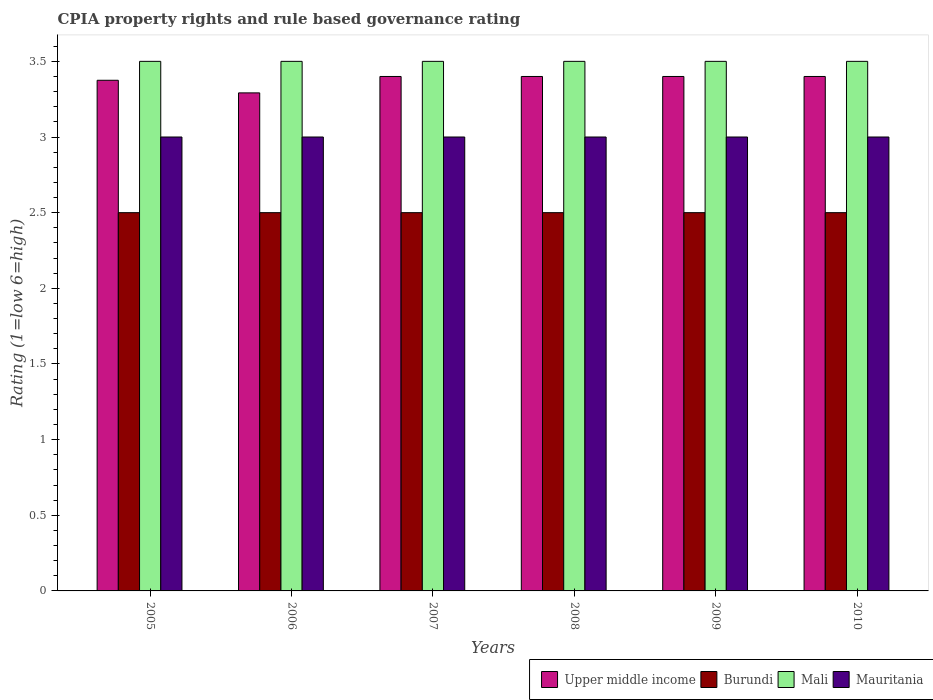How many different coloured bars are there?
Make the answer very short. 4. Are the number of bars on each tick of the X-axis equal?
Ensure brevity in your answer.  Yes. What is the label of the 2nd group of bars from the left?
Ensure brevity in your answer.  2006. What is the CPIA rating in Burundi in 2009?
Keep it short and to the point. 2.5. Across all years, what is the minimum CPIA rating in Mauritania?
Provide a succinct answer. 3. What is the total CPIA rating in Mauritania in the graph?
Provide a succinct answer. 18. What is the difference between the CPIA rating in Upper middle income in 2005 and that in 2010?
Ensure brevity in your answer.  -0.02. What is the difference between the CPIA rating in Burundi in 2008 and the CPIA rating in Upper middle income in 2007?
Your answer should be compact. -0.9. What is the average CPIA rating in Upper middle income per year?
Ensure brevity in your answer.  3.38. In how many years, is the CPIA rating in Upper middle income greater than 3.3?
Your answer should be compact. 5. Is the difference between the CPIA rating in Mauritania in 2007 and 2009 greater than the difference between the CPIA rating in Burundi in 2007 and 2009?
Offer a very short reply. No. What is the difference between the highest and the lowest CPIA rating in Mauritania?
Your answer should be compact. 0. In how many years, is the CPIA rating in Upper middle income greater than the average CPIA rating in Upper middle income taken over all years?
Your answer should be compact. 4. Is it the case that in every year, the sum of the CPIA rating in Mauritania and CPIA rating in Burundi is greater than the sum of CPIA rating in Upper middle income and CPIA rating in Mali?
Offer a terse response. Yes. What does the 4th bar from the left in 2006 represents?
Provide a short and direct response. Mauritania. What does the 1st bar from the right in 2006 represents?
Offer a terse response. Mauritania. How many bars are there?
Your answer should be very brief. 24. What is the difference between two consecutive major ticks on the Y-axis?
Ensure brevity in your answer.  0.5. Does the graph contain any zero values?
Ensure brevity in your answer.  No. Does the graph contain grids?
Ensure brevity in your answer.  No. Where does the legend appear in the graph?
Your answer should be very brief. Bottom right. How many legend labels are there?
Keep it short and to the point. 4. How are the legend labels stacked?
Provide a succinct answer. Horizontal. What is the title of the graph?
Keep it short and to the point. CPIA property rights and rule based governance rating. What is the label or title of the X-axis?
Your answer should be very brief. Years. What is the label or title of the Y-axis?
Give a very brief answer. Rating (1=low 6=high). What is the Rating (1=low 6=high) in Upper middle income in 2005?
Your answer should be compact. 3.38. What is the Rating (1=low 6=high) of Upper middle income in 2006?
Offer a very short reply. 3.29. What is the Rating (1=low 6=high) in Burundi in 2006?
Provide a succinct answer. 2.5. What is the Rating (1=low 6=high) in Upper middle income in 2007?
Offer a very short reply. 3.4. What is the Rating (1=low 6=high) of Mauritania in 2007?
Your response must be concise. 3. What is the Rating (1=low 6=high) of Burundi in 2008?
Your answer should be compact. 2.5. What is the Rating (1=low 6=high) of Mali in 2008?
Your response must be concise. 3.5. What is the Rating (1=low 6=high) of Mauritania in 2008?
Provide a short and direct response. 3. What is the Rating (1=low 6=high) of Burundi in 2009?
Ensure brevity in your answer.  2.5. What is the Rating (1=low 6=high) in Mali in 2009?
Offer a terse response. 3.5. What is the Rating (1=low 6=high) of Mauritania in 2009?
Provide a short and direct response. 3. What is the Rating (1=low 6=high) of Upper middle income in 2010?
Your response must be concise. 3.4. What is the Rating (1=low 6=high) in Mali in 2010?
Offer a terse response. 3.5. What is the Rating (1=low 6=high) of Mauritania in 2010?
Give a very brief answer. 3. Across all years, what is the maximum Rating (1=low 6=high) in Burundi?
Your response must be concise. 2.5. Across all years, what is the maximum Rating (1=low 6=high) of Mali?
Make the answer very short. 3.5. Across all years, what is the minimum Rating (1=low 6=high) in Upper middle income?
Offer a very short reply. 3.29. Across all years, what is the minimum Rating (1=low 6=high) of Burundi?
Offer a very short reply. 2.5. Across all years, what is the minimum Rating (1=low 6=high) in Mali?
Offer a very short reply. 3.5. What is the total Rating (1=low 6=high) in Upper middle income in the graph?
Provide a succinct answer. 20.27. What is the total Rating (1=low 6=high) in Mali in the graph?
Your answer should be compact. 21. What is the difference between the Rating (1=low 6=high) of Upper middle income in 2005 and that in 2006?
Provide a succinct answer. 0.08. What is the difference between the Rating (1=low 6=high) in Mauritania in 2005 and that in 2006?
Your answer should be very brief. 0. What is the difference between the Rating (1=low 6=high) of Upper middle income in 2005 and that in 2007?
Your answer should be very brief. -0.03. What is the difference between the Rating (1=low 6=high) of Upper middle income in 2005 and that in 2008?
Ensure brevity in your answer.  -0.03. What is the difference between the Rating (1=low 6=high) in Burundi in 2005 and that in 2008?
Offer a very short reply. 0. What is the difference between the Rating (1=low 6=high) of Mali in 2005 and that in 2008?
Give a very brief answer. 0. What is the difference between the Rating (1=low 6=high) in Upper middle income in 2005 and that in 2009?
Your answer should be compact. -0.03. What is the difference between the Rating (1=low 6=high) in Mali in 2005 and that in 2009?
Provide a short and direct response. 0. What is the difference between the Rating (1=low 6=high) in Mauritania in 2005 and that in 2009?
Ensure brevity in your answer.  0. What is the difference between the Rating (1=low 6=high) of Upper middle income in 2005 and that in 2010?
Ensure brevity in your answer.  -0.03. What is the difference between the Rating (1=low 6=high) of Burundi in 2005 and that in 2010?
Your answer should be very brief. 0. What is the difference between the Rating (1=low 6=high) in Mali in 2005 and that in 2010?
Your answer should be very brief. 0. What is the difference between the Rating (1=low 6=high) of Upper middle income in 2006 and that in 2007?
Keep it short and to the point. -0.11. What is the difference between the Rating (1=low 6=high) in Mali in 2006 and that in 2007?
Offer a very short reply. 0. What is the difference between the Rating (1=low 6=high) of Upper middle income in 2006 and that in 2008?
Your answer should be compact. -0.11. What is the difference between the Rating (1=low 6=high) in Upper middle income in 2006 and that in 2009?
Make the answer very short. -0.11. What is the difference between the Rating (1=low 6=high) of Mali in 2006 and that in 2009?
Give a very brief answer. 0. What is the difference between the Rating (1=low 6=high) of Upper middle income in 2006 and that in 2010?
Give a very brief answer. -0.11. What is the difference between the Rating (1=low 6=high) in Burundi in 2006 and that in 2010?
Your answer should be very brief. 0. What is the difference between the Rating (1=low 6=high) in Mali in 2006 and that in 2010?
Make the answer very short. 0. What is the difference between the Rating (1=low 6=high) in Mauritania in 2006 and that in 2010?
Keep it short and to the point. 0. What is the difference between the Rating (1=low 6=high) in Upper middle income in 2007 and that in 2008?
Ensure brevity in your answer.  0. What is the difference between the Rating (1=low 6=high) in Mauritania in 2007 and that in 2008?
Offer a very short reply. 0. What is the difference between the Rating (1=low 6=high) in Burundi in 2007 and that in 2009?
Your answer should be compact. 0. What is the difference between the Rating (1=low 6=high) of Mali in 2007 and that in 2010?
Your answer should be very brief. 0. What is the difference between the Rating (1=low 6=high) of Mauritania in 2007 and that in 2010?
Give a very brief answer. 0. What is the difference between the Rating (1=low 6=high) in Burundi in 2008 and that in 2009?
Provide a short and direct response. 0. What is the difference between the Rating (1=low 6=high) of Mauritania in 2008 and that in 2009?
Your answer should be compact. 0. What is the difference between the Rating (1=low 6=high) in Upper middle income in 2008 and that in 2010?
Make the answer very short. 0. What is the difference between the Rating (1=low 6=high) in Mauritania in 2008 and that in 2010?
Provide a succinct answer. 0. What is the difference between the Rating (1=low 6=high) of Upper middle income in 2009 and that in 2010?
Offer a terse response. 0. What is the difference between the Rating (1=low 6=high) of Burundi in 2009 and that in 2010?
Ensure brevity in your answer.  0. What is the difference between the Rating (1=low 6=high) in Mali in 2009 and that in 2010?
Your response must be concise. 0. What is the difference between the Rating (1=low 6=high) of Mauritania in 2009 and that in 2010?
Give a very brief answer. 0. What is the difference between the Rating (1=low 6=high) of Upper middle income in 2005 and the Rating (1=low 6=high) of Burundi in 2006?
Your response must be concise. 0.88. What is the difference between the Rating (1=low 6=high) of Upper middle income in 2005 and the Rating (1=low 6=high) of Mali in 2006?
Make the answer very short. -0.12. What is the difference between the Rating (1=low 6=high) in Mali in 2005 and the Rating (1=low 6=high) in Mauritania in 2006?
Give a very brief answer. 0.5. What is the difference between the Rating (1=low 6=high) of Upper middle income in 2005 and the Rating (1=low 6=high) of Mali in 2007?
Provide a succinct answer. -0.12. What is the difference between the Rating (1=low 6=high) in Upper middle income in 2005 and the Rating (1=low 6=high) in Mauritania in 2007?
Give a very brief answer. 0.38. What is the difference between the Rating (1=low 6=high) in Mali in 2005 and the Rating (1=low 6=high) in Mauritania in 2007?
Your answer should be compact. 0.5. What is the difference between the Rating (1=low 6=high) in Upper middle income in 2005 and the Rating (1=low 6=high) in Mali in 2008?
Your answer should be very brief. -0.12. What is the difference between the Rating (1=low 6=high) in Burundi in 2005 and the Rating (1=low 6=high) in Mauritania in 2008?
Give a very brief answer. -0.5. What is the difference between the Rating (1=low 6=high) of Mali in 2005 and the Rating (1=low 6=high) of Mauritania in 2008?
Ensure brevity in your answer.  0.5. What is the difference between the Rating (1=low 6=high) of Upper middle income in 2005 and the Rating (1=low 6=high) of Burundi in 2009?
Offer a terse response. 0.88. What is the difference between the Rating (1=low 6=high) of Upper middle income in 2005 and the Rating (1=low 6=high) of Mali in 2009?
Your response must be concise. -0.12. What is the difference between the Rating (1=low 6=high) in Mali in 2005 and the Rating (1=low 6=high) in Mauritania in 2009?
Make the answer very short. 0.5. What is the difference between the Rating (1=low 6=high) of Upper middle income in 2005 and the Rating (1=low 6=high) of Burundi in 2010?
Provide a succinct answer. 0.88. What is the difference between the Rating (1=low 6=high) in Upper middle income in 2005 and the Rating (1=low 6=high) in Mali in 2010?
Your answer should be compact. -0.12. What is the difference between the Rating (1=low 6=high) in Upper middle income in 2005 and the Rating (1=low 6=high) in Mauritania in 2010?
Provide a succinct answer. 0.38. What is the difference between the Rating (1=low 6=high) of Burundi in 2005 and the Rating (1=low 6=high) of Mali in 2010?
Give a very brief answer. -1. What is the difference between the Rating (1=low 6=high) of Mali in 2005 and the Rating (1=low 6=high) of Mauritania in 2010?
Provide a short and direct response. 0.5. What is the difference between the Rating (1=low 6=high) in Upper middle income in 2006 and the Rating (1=low 6=high) in Burundi in 2007?
Make the answer very short. 0.79. What is the difference between the Rating (1=low 6=high) of Upper middle income in 2006 and the Rating (1=low 6=high) of Mali in 2007?
Offer a terse response. -0.21. What is the difference between the Rating (1=low 6=high) in Upper middle income in 2006 and the Rating (1=low 6=high) in Mauritania in 2007?
Your answer should be very brief. 0.29. What is the difference between the Rating (1=low 6=high) of Burundi in 2006 and the Rating (1=low 6=high) of Mali in 2007?
Ensure brevity in your answer.  -1. What is the difference between the Rating (1=low 6=high) in Burundi in 2006 and the Rating (1=low 6=high) in Mauritania in 2007?
Provide a short and direct response. -0.5. What is the difference between the Rating (1=low 6=high) of Upper middle income in 2006 and the Rating (1=low 6=high) of Burundi in 2008?
Make the answer very short. 0.79. What is the difference between the Rating (1=low 6=high) in Upper middle income in 2006 and the Rating (1=low 6=high) in Mali in 2008?
Your response must be concise. -0.21. What is the difference between the Rating (1=low 6=high) in Upper middle income in 2006 and the Rating (1=low 6=high) in Mauritania in 2008?
Give a very brief answer. 0.29. What is the difference between the Rating (1=low 6=high) of Burundi in 2006 and the Rating (1=low 6=high) of Mauritania in 2008?
Provide a succinct answer. -0.5. What is the difference between the Rating (1=low 6=high) in Upper middle income in 2006 and the Rating (1=low 6=high) in Burundi in 2009?
Your response must be concise. 0.79. What is the difference between the Rating (1=low 6=high) in Upper middle income in 2006 and the Rating (1=low 6=high) in Mali in 2009?
Keep it short and to the point. -0.21. What is the difference between the Rating (1=low 6=high) of Upper middle income in 2006 and the Rating (1=low 6=high) of Mauritania in 2009?
Your answer should be very brief. 0.29. What is the difference between the Rating (1=low 6=high) in Mali in 2006 and the Rating (1=low 6=high) in Mauritania in 2009?
Ensure brevity in your answer.  0.5. What is the difference between the Rating (1=low 6=high) in Upper middle income in 2006 and the Rating (1=low 6=high) in Burundi in 2010?
Keep it short and to the point. 0.79. What is the difference between the Rating (1=low 6=high) of Upper middle income in 2006 and the Rating (1=low 6=high) of Mali in 2010?
Keep it short and to the point. -0.21. What is the difference between the Rating (1=low 6=high) of Upper middle income in 2006 and the Rating (1=low 6=high) of Mauritania in 2010?
Give a very brief answer. 0.29. What is the difference between the Rating (1=low 6=high) in Burundi in 2006 and the Rating (1=low 6=high) in Mali in 2010?
Your response must be concise. -1. What is the difference between the Rating (1=low 6=high) in Upper middle income in 2007 and the Rating (1=low 6=high) in Burundi in 2008?
Offer a terse response. 0.9. What is the difference between the Rating (1=low 6=high) of Burundi in 2007 and the Rating (1=low 6=high) of Mali in 2008?
Provide a short and direct response. -1. What is the difference between the Rating (1=low 6=high) in Mali in 2007 and the Rating (1=low 6=high) in Mauritania in 2008?
Offer a very short reply. 0.5. What is the difference between the Rating (1=low 6=high) in Upper middle income in 2007 and the Rating (1=low 6=high) in Mauritania in 2009?
Offer a terse response. 0.4. What is the difference between the Rating (1=low 6=high) in Burundi in 2007 and the Rating (1=low 6=high) in Mauritania in 2009?
Ensure brevity in your answer.  -0.5. What is the difference between the Rating (1=low 6=high) in Mali in 2007 and the Rating (1=low 6=high) in Mauritania in 2009?
Your answer should be very brief. 0.5. What is the difference between the Rating (1=low 6=high) in Upper middle income in 2007 and the Rating (1=low 6=high) in Mali in 2010?
Provide a short and direct response. -0.1. What is the difference between the Rating (1=low 6=high) of Burundi in 2007 and the Rating (1=low 6=high) of Mauritania in 2010?
Offer a very short reply. -0.5. What is the difference between the Rating (1=low 6=high) in Upper middle income in 2008 and the Rating (1=low 6=high) in Burundi in 2009?
Your response must be concise. 0.9. What is the difference between the Rating (1=low 6=high) of Upper middle income in 2008 and the Rating (1=low 6=high) of Mali in 2009?
Provide a succinct answer. -0.1. What is the difference between the Rating (1=low 6=high) of Burundi in 2008 and the Rating (1=low 6=high) of Mauritania in 2009?
Offer a very short reply. -0.5. What is the difference between the Rating (1=low 6=high) in Mali in 2008 and the Rating (1=low 6=high) in Mauritania in 2009?
Offer a very short reply. 0.5. What is the difference between the Rating (1=low 6=high) in Upper middle income in 2008 and the Rating (1=low 6=high) in Burundi in 2010?
Your answer should be very brief. 0.9. What is the difference between the Rating (1=low 6=high) in Upper middle income in 2008 and the Rating (1=low 6=high) in Mali in 2010?
Give a very brief answer. -0.1. What is the difference between the Rating (1=low 6=high) in Burundi in 2008 and the Rating (1=low 6=high) in Mali in 2010?
Offer a very short reply. -1. What is the difference between the Rating (1=low 6=high) in Burundi in 2008 and the Rating (1=low 6=high) in Mauritania in 2010?
Make the answer very short. -0.5. What is the difference between the Rating (1=low 6=high) in Upper middle income in 2009 and the Rating (1=low 6=high) in Mauritania in 2010?
Offer a very short reply. 0.4. What is the difference between the Rating (1=low 6=high) in Mali in 2009 and the Rating (1=low 6=high) in Mauritania in 2010?
Make the answer very short. 0.5. What is the average Rating (1=low 6=high) in Upper middle income per year?
Provide a succinct answer. 3.38. What is the average Rating (1=low 6=high) in Burundi per year?
Your answer should be very brief. 2.5. What is the average Rating (1=low 6=high) of Mali per year?
Your answer should be compact. 3.5. What is the average Rating (1=low 6=high) in Mauritania per year?
Make the answer very short. 3. In the year 2005, what is the difference between the Rating (1=low 6=high) in Upper middle income and Rating (1=low 6=high) in Mali?
Provide a short and direct response. -0.12. In the year 2005, what is the difference between the Rating (1=low 6=high) of Upper middle income and Rating (1=low 6=high) of Mauritania?
Your answer should be compact. 0.38. In the year 2005, what is the difference between the Rating (1=low 6=high) in Burundi and Rating (1=low 6=high) in Mali?
Provide a succinct answer. -1. In the year 2005, what is the difference between the Rating (1=low 6=high) of Mali and Rating (1=low 6=high) of Mauritania?
Make the answer very short. 0.5. In the year 2006, what is the difference between the Rating (1=low 6=high) of Upper middle income and Rating (1=low 6=high) of Burundi?
Make the answer very short. 0.79. In the year 2006, what is the difference between the Rating (1=low 6=high) in Upper middle income and Rating (1=low 6=high) in Mali?
Provide a succinct answer. -0.21. In the year 2006, what is the difference between the Rating (1=low 6=high) of Upper middle income and Rating (1=low 6=high) of Mauritania?
Your answer should be compact. 0.29. In the year 2006, what is the difference between the Rating (1=low 6=high) of Burundi and Rating (1=low 6=high) of Mali?
Give a very brief answer. -1. In the year 2006, what is the difference between the Rating (1=low 6=high) in Burundi and Rating (1=low 6=high) in Mauritania?
Provide a succinct answer. -0.5. In the year 2007, what is the difference between the Rating (1=low 6=high) in Upper middle income and Rating (1=low 6=high) in Mauritania?
Your response must be concise. 0.4. In the year 2007, what is the difference between the Rating (1=low 6=high) of Burundi and Rating (1=low 6=high) of Mauritania?
Your answer should be very brief. -0.5. In the year 2008, what is the difference between the Rating (1=low 6=high) in Upper middle income and Rating (1=low 6=high) in Mali?
Ensure brevity in your answer.  -0.1. In the year 2008, what is the difference between the Rating (1=low 6=high) of Burundi and Rating (1=low 6=high) of Mali?
Give a very brief answer. -1. In the year 2008, what is the difference between the Rating (1=low 6=high) in Burundi and Rating (1=low 6=high) in Mauritania?
Your response must be concise. -0.5. In the year 2009, what is the difference between the Rating (1=low 6=high) in Upper middle income and Rating (1=low 6=high) in Burundi?
Your answer should be very brief. 0.9. In the year 2009, what is the difference between the Rating (1=low 6=high) in Upper middle income and Rating (1=low 6=high) in Mauritania?
Keep it short and to the point. 0.4. In the year 2009, what is the difference between the Rating (1=low 6=high) in Burundi and Rating (1=low 6=high) in Mali?
Provide a succinct answer. -1. In the year 2009, what is the difference between the Rating (1=low 6=high) of Burundi and Rating (1=low 6=high) of Mauritania?
Offer a very short reply. -0.5. In the year 2009, what is the difference between the Rating (1=low 6=high) in Mali and Rating (1=low 6=high) in Mauritania?
Your answer should be very brief. 0.5. In the year 2010, what is the difference between the Rating (1=low 6=high) in Upper middle income and Rating (1=low 6=high) in Burundi?
Offer a terse response. 0.9. In the year 2010, what is the difference between the Rating (1=low 6=high) of Burundi and Rating (1=low 6=high) of Mali?
Offer a very short reply. -1. What is the ratio of the Rating (1=low 6=high) in Upper middle income in 2005 to that in 2006?
Provide a succinct answer. 1.03. What is the ratio of the Rating (1=low 6=high) of Burundi in 2005 to that in 2007?
Offer a terse response. 1. What is the ratio of the Rating (1=low 6=high) in Mali in 2005 to that in 2007?
Provide a short and direct response. 1. What is the ratio of the Rating (1=low 6=high) in Burundi in 2005 to that in 2008?
Make the answer very short. 1. What is the ratio of the Rating (1=low 6=high) in Mali in 2005 to that in 2008?
Provide a succinct answer. 1. What is the ratio of the Rating (1=low 6=high) of Burundi in 2005 to that in 2009?
Offer a very short reply. 1. What is the ratio of the Rating (1=low 6=high) of Mali in 2005 to that in 2009?
Your answer should be very brief. 1. What is the ratio of the Rating (1=low 6=high) of Mauritania in 2005 to that in 2009?
Offer a very short reply. 1. What is the ratio of the Rating (1=low 6=high) in Upper middle income in 2006 to that in 2007?
Give a very brief answer. 0.97. What is the ratio of the Rating (1=low 6=high) of Upper middle income in 2006 to that in 2008?
Offer a terse response. 0.97. What is the ratio of the Rating (1=low 6=high) in Burundi in 2006 to that in 2008?
Provide a succinct answer. 1. What is the ratio of the Rating (1=low 6=high) in Mali in 2006 to that in 2008?
Provide a short and direct response. 1. What is the ratio of the Rating (1=low 6=high) of Mauritania in 2006 to that in 2008?
Keep it short and to the point. 1. What is the ratio of the Rating (1=low 6=high) in Upper middle income in 2006 to that in 2009?
Provide a short and direct response. 0.97. What is the ratio of the Rating (1=low 6=high) of Burundi in 2006 to that in 2009?
Offer a terse response. 1. What is the ratio of the Rating (1=low 6=high) of Mauritania in 2006 to that in 2009?
Ensure brevity in your answer.  1. What is the ratio of the Rating (1=low 6=high) in Upper middle income in 2006 to that in 2010?
Provide a succinct answer. 0.97. What is the ratio of the Rating (1=low 6=high) in Upper middle income in 2007 to that in 2008?
Keep it short and to the point. 1. What is the ratio of the Rating (1=low 6=high) of Burundi in 2007 to that in 2008?
Offer a very short reply. 1. What is the ratio of the Rating (1=low 6=high) in Upper middle income in 2007 to that in 2009?
Make the answer very short. 1. What is the ratio of the Rating (1=low 6=high) in Burundi in 2007 to that in 2009?
Offer a terse response. 1. What is the ratio of the Rating (1=low 6=high) of Burundi in 2007 to that in 2010?
Ensure brevity in your answer.  1. What is the ratio of the Rating (1=low 6=high) in Mauritania in 2007 to that in 2010?
Give a very brief answer. 1. What is the ratio of the Rating (1=low 6=high) in Upper middle income in 2008 to that in 2009?
Give a very brief answer. 1. What is the ratio of the Rating (1=low 6=high) in Burundi in 2008 to that in 2009?
Your answer should be compact. 1. What is the ratio of the Rating (1=low 6=high) of Mali in 2008 to that in 2009?
Your response must be concise. 1. What is the ratio of the Rating (1=low 6=high) in Mauritania in 2008 to that in 2009?
Provide a succinct answer. 1. What is the ratio of the Rating (1=low 6=high) of Upper middle income in 2008 to that in 2010?
Ensure brevity in your answer.  1. What is the ratio of the Rating (1=low 6=high) of Burundi in 2008 to that in 2010?
Offer a very short reply. 1. What is the ratio of the Rating (1=low 6=high) in Upper middle income in 2009 to that in 2010?
Offer a terse response. 1. What is the ratio of the Rating (1=low 6=high) in Mauritania in 2009 to that in 2010?
Keep it short and to the point. 1. What is the difference between the highest and the second highest Rating (1=low 6=high) in Upper middle income?
Provide a succinct answer. 0. What is the difference between the highest and the second highest Rating (1=low 6=high) in Burundi?
Make the answer very short. 0. What is the difference between the highest and the second highest Rating (1=low 6=high) in Mali?
Your answer should be very brief. 0. What is the difference between the highest and the lowest Rating (1=low 6=high) in Upper middle income?
Offer a terse response. 0.11. What is the difference between the highest and the lowest Rating (1=low 6=high) of Mali?
Your answer should be very brief. 0. What is the difference between the highest and the lowest Rating (1=low 6=high) of Mauritania?
Provide a succinct answer. 0. 